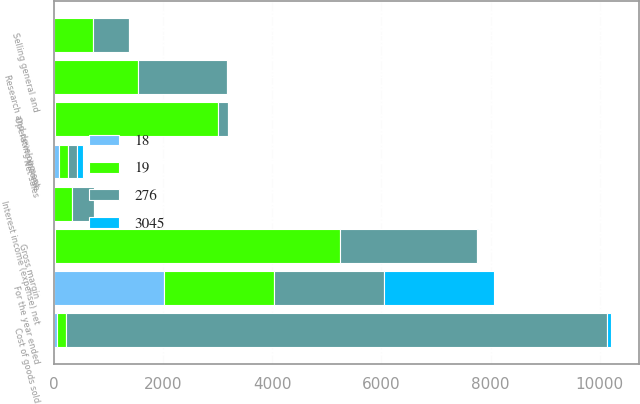<chart> <loc_0><loc_0><loc_500><loc_500><stacked_bar_chart><ecel><fcel>For the year ended<fcel>Net sales<fcel>Cost of goods sold<fcel>Gross margin<fcel>Selling general and<fcel>Research and development<fcel>Operating income<fcel>Interest income (expense) net<nl><fcel>276<fcel>2016<fcel>168<fcel>9894<fcel>2505<fcel>659<fcel>1617<fcel>168<fcel>395<nl><fcel>3045<fcel>2016<fcel>100<fcel>80<fcel>20<fcel>5<fcel>13<fcel>1<fcel>3<nl><fcel>19<fcel>2015<fcel>168<fcel>168<fcel>5215<fcel>719<fcel>1540<fcel>2998<fcel>336<nl><fcel>18<fcel>2015<fcel>100<fcel>68<fcel>32<fcel>4<fcel>10<fcel>19<fcel>2<nl></chart> 